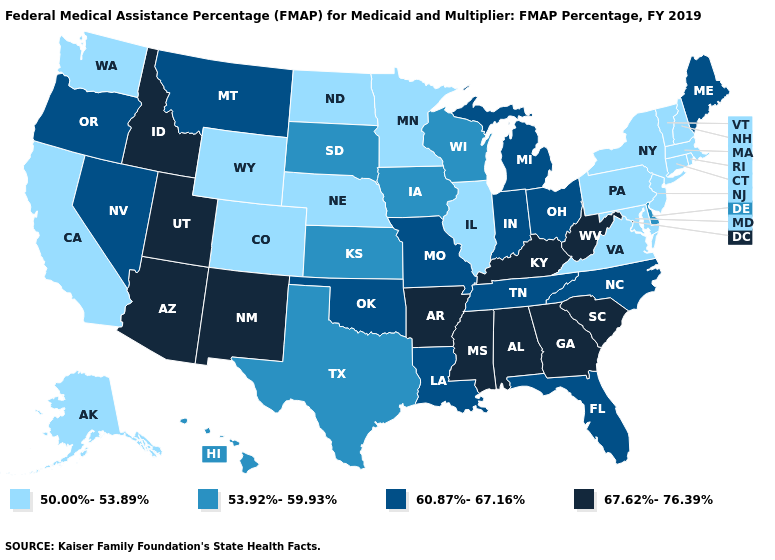What is the lowest value in the South?
Quick response, please. 50.00%-53.89%. Name the states that have a value in the range 50.00%-53.89%?
Be succinct. Alaska, California, Colorado, Connecticut, Illinois, Maryland, Massachusetts, Minnesota, Nebraska, New Hampshire, New Jersey, New York, North Dakota, Pennsylvania, Rhode Island, Vermont, Virginia, Washington, Wyoming. What is the value of Rhode Island?
Quick response, please. 50.00%-53.89%. Does Utah have the highest value in the USA?
Concise answer only. Yes. Name the states that have a value in the range 67.62%-76.39%?
Concise answer only. Alabama, Arizona, Arkansas, Georgia, Idaho, Kentucky, Mississippi, New Mexico, South Carolina, Utah, West Virginia. What is the value of Michigan?
Quick response, please. 60.87%-67.16%. Does Delaware have the lowest value in the South?
Write a very short answer. No. Which states hav the highest value in the West?
Give a very brief answer. Arizona, Idaho, New Mexico, Utah. Among the states that border Connecticut , which have the highest value?
Write a very short answer. Massachusetts, New York, Rhode Island. Name the states that have a value in the range 50.00%-53.89%?
Give a very brief answer. Alaska, California, Colorado, Connecticut, Illinois, Maryland, Massachusetts, Minnesota, Nebraska, New Hampshire, New Jersey, New York, North Dakota, Pennsylvania, Rhode Island, Vermont, Virginia, Washington, Wyoming. What is the value of Washington?
Quick response, please. 50.00%-53.89%. What is the value of Michigan?
Keep it brief. 60.87%-67.16%. Name the states that have a value in the range 53.92%-59.93%?
Answer briefly. Delaware, Hawaii, Iowa, Kansas, South Dakota, Texas, Wisconsin. What is the lowest value in the MidWest?
Answer briefly. 50.00%-53.89%. Name the states that have a value in the range 67.62%-76.39%?
Answer briefly. Alabama, Arizona, Arkansas, Georgia, Idaho, Kentucky, Mississippi, New Mexico, South Carolina, Utah, West Virginia. 